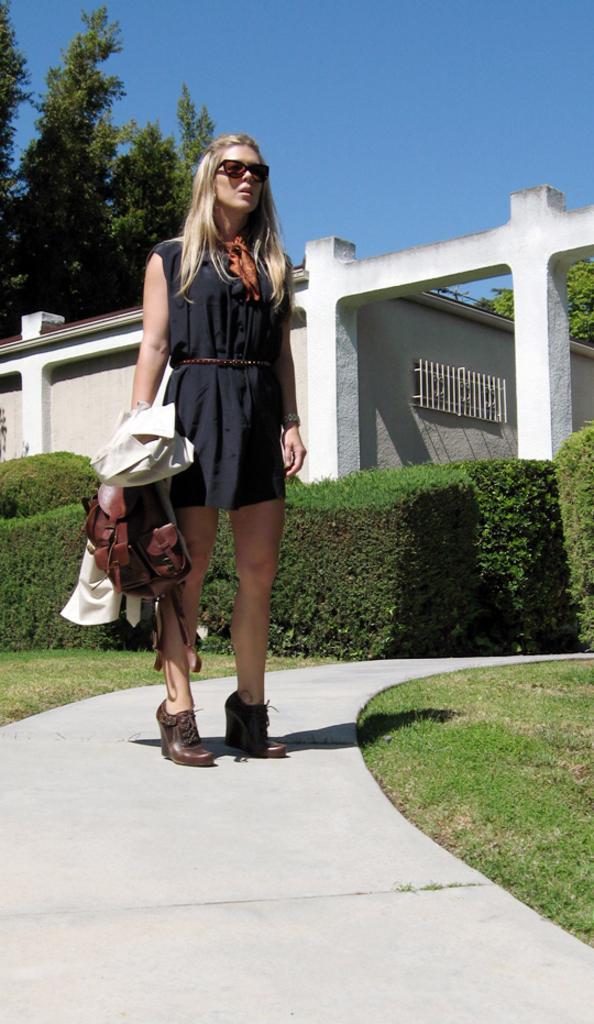Can you describe this image briefly? In the center of the image there is a person standing on the road. She is holding the bag and a jacket. On both right and left side of the image there is grass on the surface. In the background of the image there are plants. There is a building. There are trees and sky. 